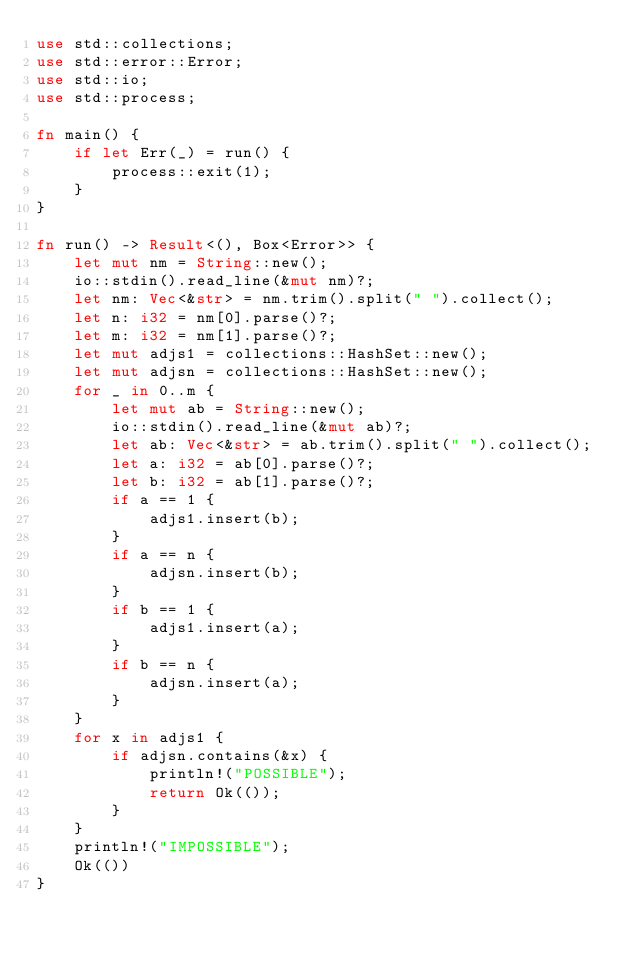Convert code to text. <code><loc_0><loc_0><loc_500><loc_500><_Rust_>use std::collections;
use std::error::Error;
use std::io;
use std::process;

fn main() {
    if let Err(_) = run() {
        process::exit(1);
    }
}

fn run() -> Result<(), Box<Error>> {
    let mut nm = String::new();
    io::stdin().read_line(&mut nm)?;
    let nm: Vec<&str> = nm.trim().split(" ").collect();
    let n: i32 = nm[0].parse()?;
    let m: i32 = nm[1].parse()?;
    let mut adjs1 = collections::HashSet::new();
    let mut adjsn = collections::HashSet::new();
    for _ in 0..m {
        let mut ab = String::new();
        io::stdin().read_line(&mut ab)?;
        let ab: Vec<&str> = ab.trim().split(" ").collect();
        let a: i32 = ab[0].parse()?;
        let b: i32 = ab[1].parse()?;
        if a == 1 {
            adjs1.insert(b);
        }
        if a == n {
            adjsn.insert(b);
        }
        if b == 1 {
            adjs1.insert(a);
        }
        if b == n {
            adjsn.insert(a);
        }
    }
    for x in adjs1 {
        if adjsn.contains(&x) {
            println!("POSSIBLE");
            return Ok(());
        }
    }
    println!("IMPOSSIBLE");
    Ok(())
}
</code> 